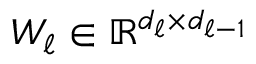Convert formula to latex. <formula><loc_0><loc_0><loc_500><loc_500>W _ { \ell } \in \mathbb { R } ^ { d _ { \ell } \times d _ { \ell - 1 } }</formula> 